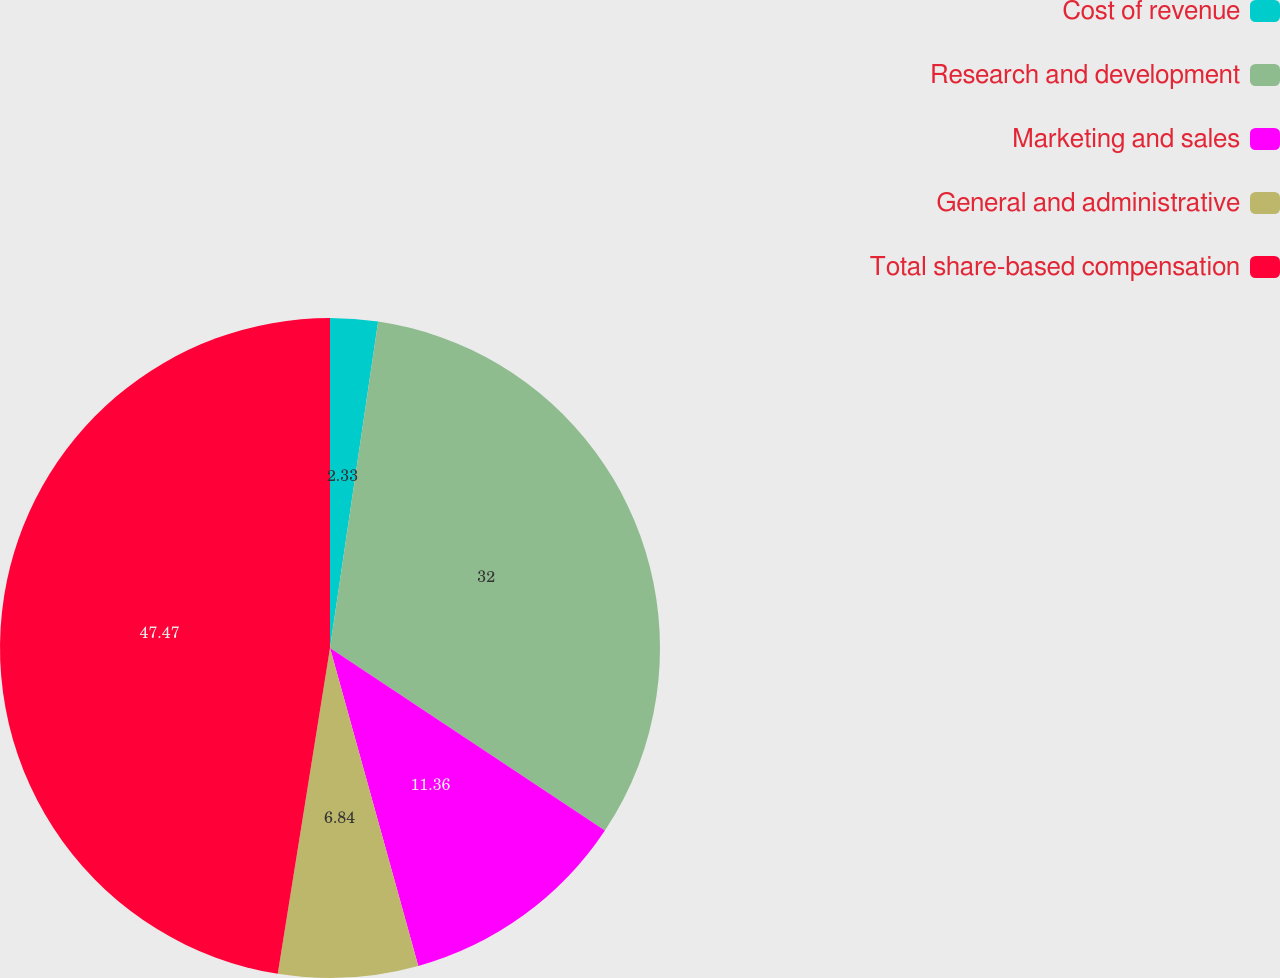Convert chart. <chart><loc_0><loc_0><loc_500><loc_500><pie_chart><fcel>Cost of revenue<fcel>Research and development<fcel>Marketing and sales<fcel>General and administrative<fcel>Total share-based compensation<nl><fcel>2.33%<fcel>32.0%<fcel>11.36%<fcel>6.84%<fcel>47.47%<nl></chart> 